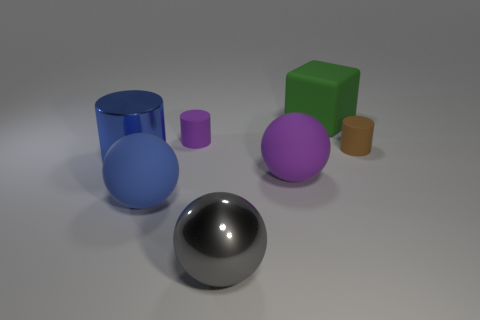Add 1 big green rubber things. How many big green rubber things are left? 2 Add 3 large blue things. How many large blue things exist? 5 Add 3 cyan rubber objects. How many objects exist? 10 Subtract all purple spheres. How many spheres are left? 2 Subtract all metallic balls. How many balls are left? 2 Subtract 0 green spheres. How many objects are left? 7 Subtract all cylinders. How many objects are left? 4 Subtract 1 cylinders. How many cylinders are left? 2 Subtract all yellow cylinders. Subtract all brown balls. How many cylinders are left? 3 Subtract all red cylinders. How many purple spheres are left? 1 